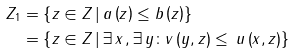Convert formula to latex. <formula><loc_0><loc_0><loc_500><loc_500>Z _ { 1 } & = \left \{ z \in Z \, | \, a \left ( z \right ) \leq b \left ( z \right ) \right \} \\ & = \left \{ z \in Z \, | \, \exists \, x \, , \exists \, y \colon v \left ( y , z \right ) \leq \, u \left ( x , z \right ) \right \}</formula> 